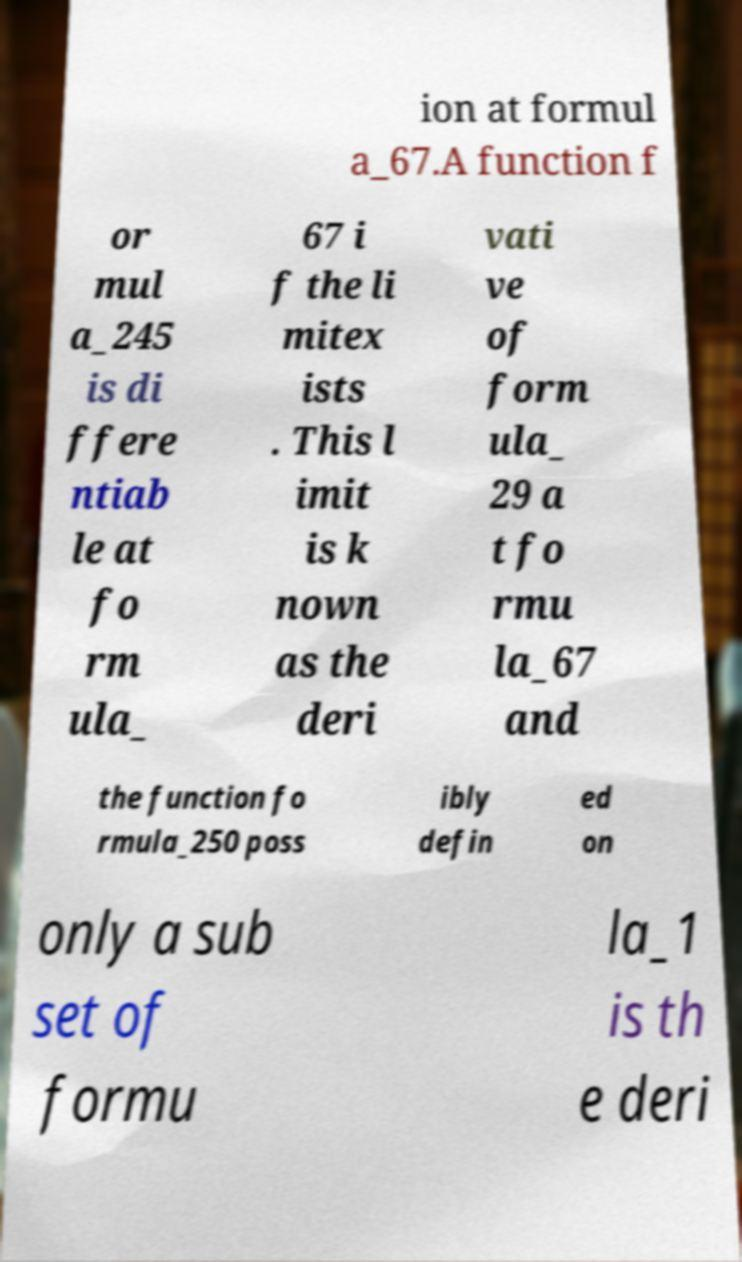What messages or text are displayed in this image? I need them in a readable, typed format. ion at formul a_67.A function f or mul a_245 is di ffere ntiab le at fo rm ula_ 67 i f the li mitex ists . This l imit is k nown as the deri vati ve of form ula_ 29 a t fo rmu la_67 and the function fo rmula_250 poss ibly defin ed on only a sub set of formu la_1 is th e deri 